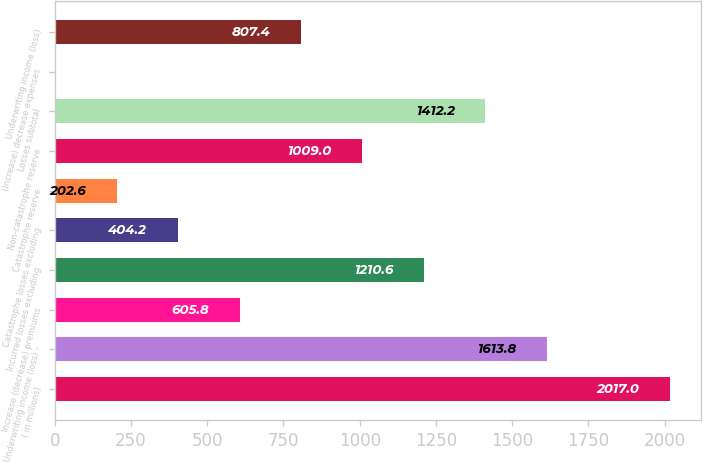<chart> <loc_0><loc_0><loc_500><loc_500><bar_chart><fcel>( in millions)<fcel>Underwriting income (loss) -<fcel>Increase (decrease) premiums<fcel>Incurred losses excluding<fcel>Catastrophe losses excluding<fcel>Catastrophe reserve<fcel>Non-catastrophe reserve<fcel>Losses subtotal<fcel>(Increase) decrease expenses<fcel>Underwriting income (loss)<nl><fcel>2017<fcel>1613.8<fcel>605.8<fcel>1210.6<fcel>404.2<fcel>202.6<fcel>1009<fcel>1412.2<fcel>1<fcel>807.4<nl></chart> 